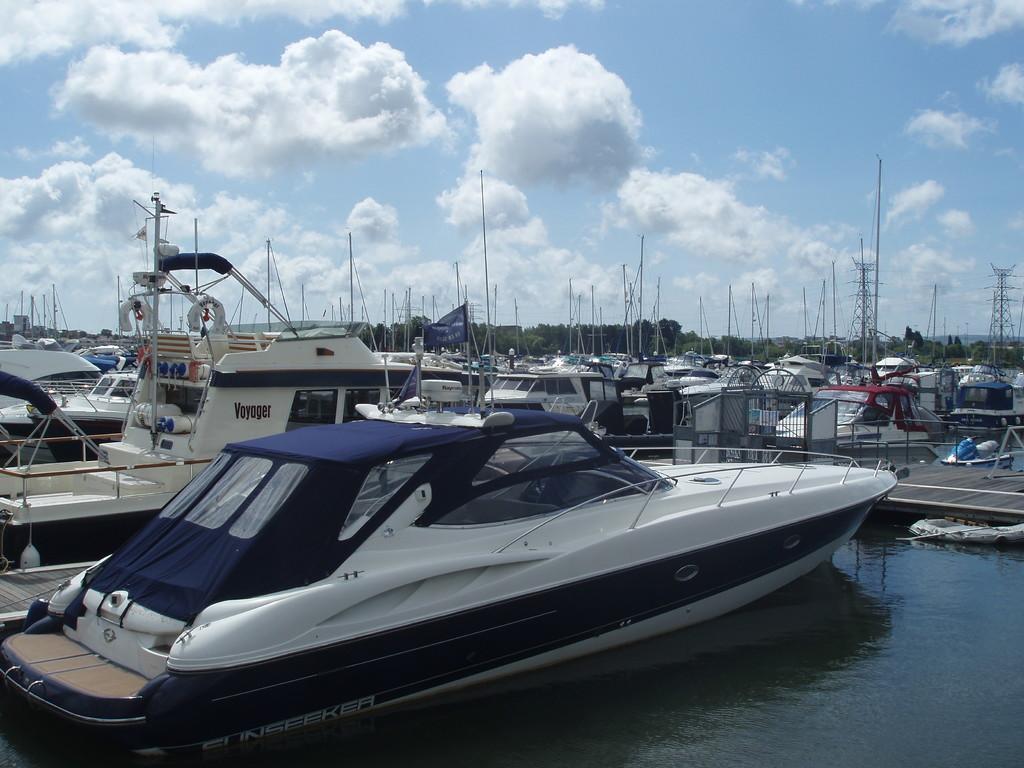Describe this image in one or two sentences. In this image few boats are on the surface of the water. Right side there is a bridge. There are few transmission towers. Background there are trees. Top of the image there is sky. 